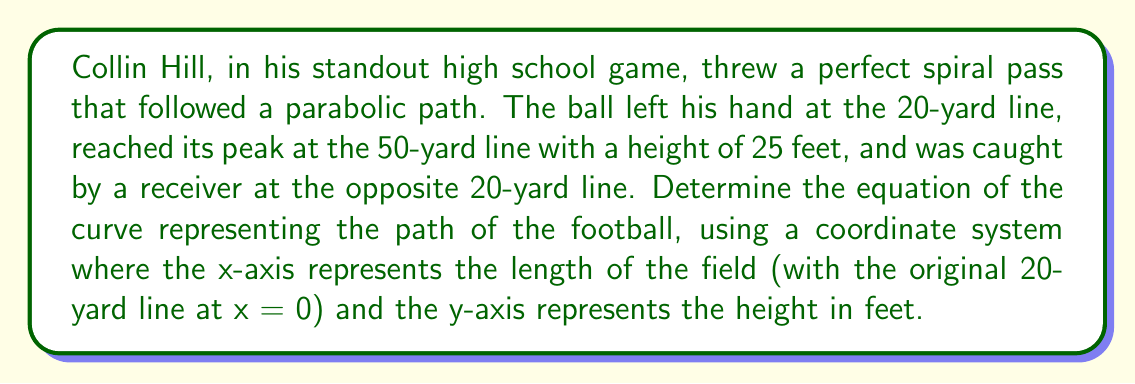Could you help me with this problem? Let's approach this step-by-step:

1) We know that the path of the football forms a parabola, which has the general equation:

   $$ y = ax^2 + bx + c $$

2) We have three points on this parabola:
   - Start: (0, 0)
   - Peak: (30, 25)
   - End: (60, 0)

3) Let's substitute these points into the general equation:

   For (0, 0): $0 = a(0)^2 + b(0) + c$, so $c = 0$
   For (30, 25): $25 = a(30)^2 + b(30)$
   For (60, 0): $0 = a(60)^2 + b(60)$

4) We now have two equations:
   $25 = 900a + 30b$ ... (1)
   $0 = 3600a + 60b$ ... (2)

5) Multiply equation (1) by 2 and equation (2) by -1:
   $50 = 1800a + 60b$ ... (3)
   $0 = -3600a - 60b$ ... (4)

6) Add equations (3) and (4):
   $50 = -1800a$
   $a = -\frac{1}{36}$

7) Substitute this value of $a$ into equation (1):
   $25 = 900(-\frac{1}{36}) + 30b$
   $25 = -25 + 30b$
   $50 = 30b$
   $b = \frac{5}{3}$

8) Therefore, the equation of the curve is:

   $$ y = -\frac{1}{36}x^2 + \frac{5}{3}x $$
Answer: $y = -\frac{1}{36}x^2 + \frac{5}{3}x$ 